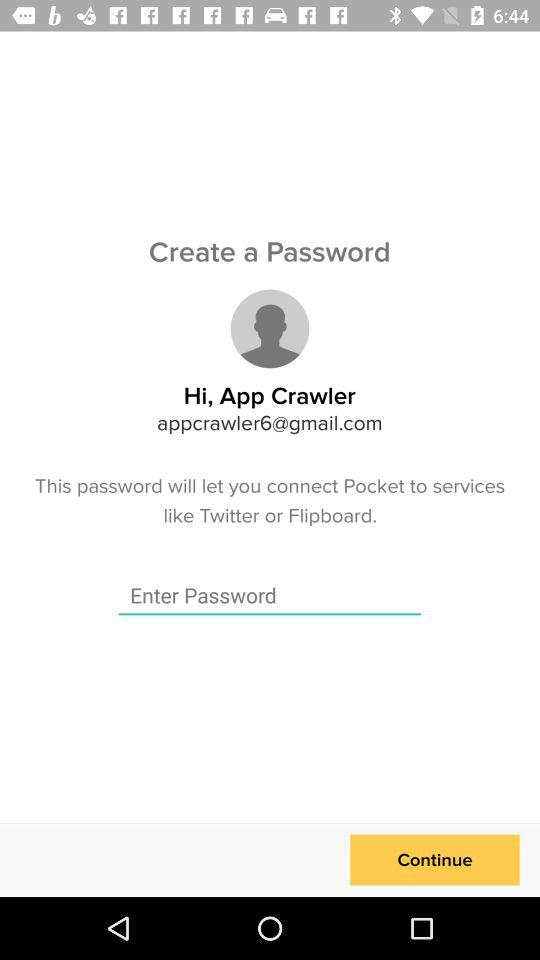What is the email address? The email address is appcrawler6@gmail.com. 